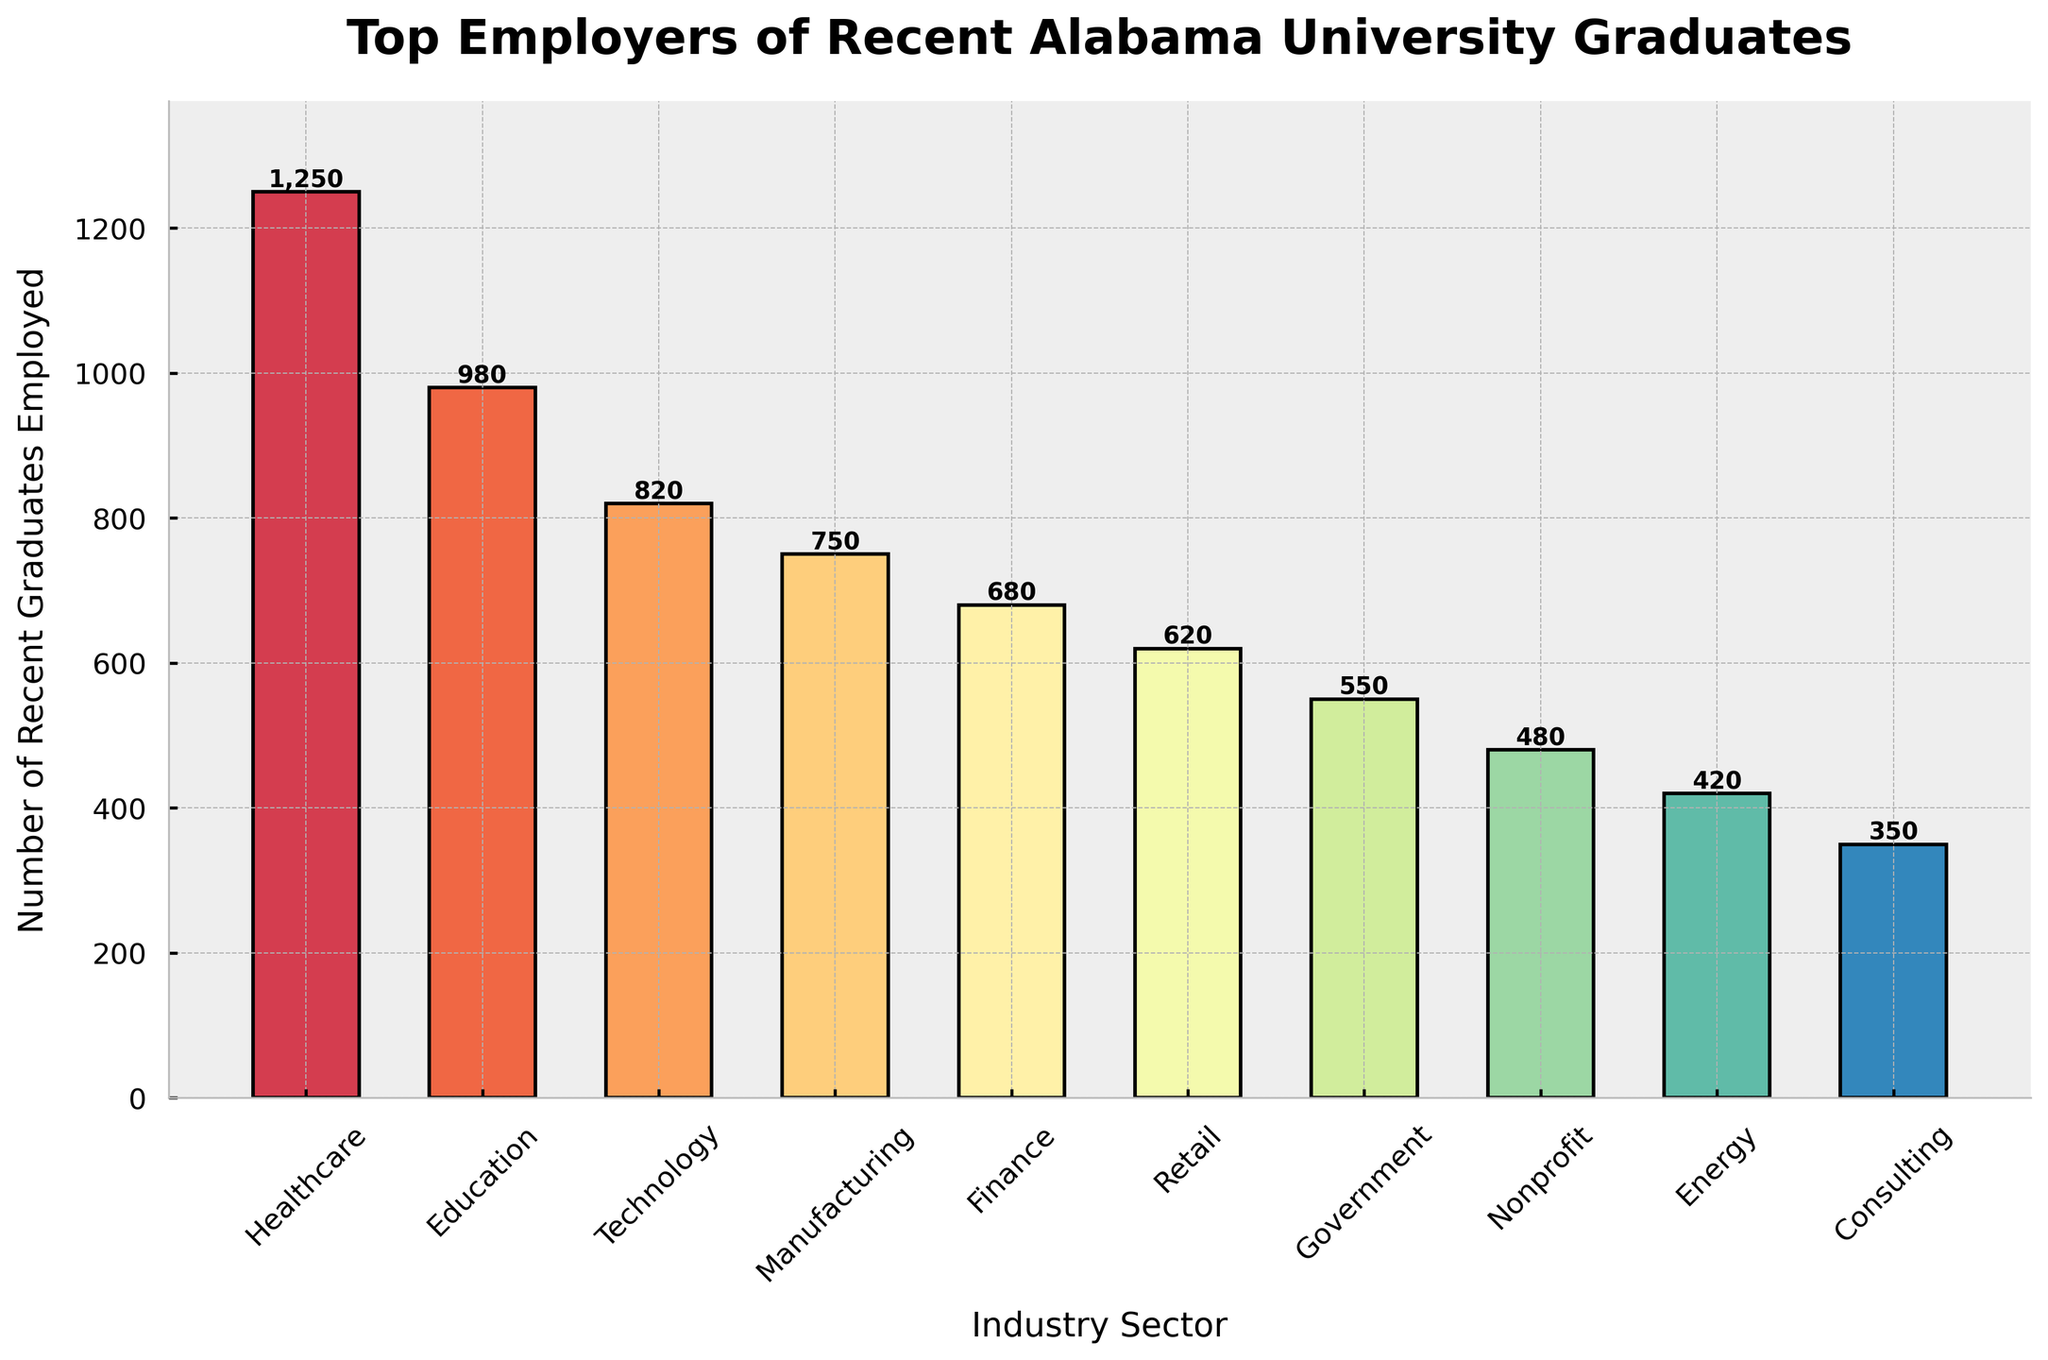Which industry sector employs the most recent graduates? The bar chart indicates that the 'Healthcare' sector has the highest bar, which represents 1,250 recent graduates employed
Answer: Healthcare How many more graduates are employed in Healthcare compared to Technology? The figure shows 1,250 graduates in Healthcare and 820 in Technology. The difference is 1,250 - 820 = 430
Answer: 430 Which industry sector employs the fewest recent graduates? The 'Consulting' sector has the shortest bar in the chart, representing 350 recent graduates employed
Answer: Consulting What is the total number of recent graduates employed in the top three industry sectors? The top three sectors are Healthcare (1,250), Education (980), and Technology (820). Summing these up: 1,250 + 980 + 820 = 3,050
Answer: 3,050 Which industry sectors employ more than 600 recent graduates? From the chart, the sectors that employ more than 600 graduates are Healthcare (1,250), Education (980), Technology (820), Manufacturing (750), and Finance (680)
Answer: Healthcare, Education, Technology, Manufacturing, Finance How does the number of graduates employed in the Government sector compare to the Finance sector? Government employs 550 graduates, and Finance employs 680 graduates. The Government sector employs fewer graduates by 680 - 550 = 130
Answer: 130 fewer What is the combined number of graduates employed in the Nonprofit and Energy sectors? Nonprofit employs 480 graduates, and Energy employs 420 graduates. Their combined number is 480 + 420 = 900
Answer: 900 Which sectors have a difference in graduate employment of more than 200 compared to Manufacturing? Manufacturing employs 750 graduates. Healthcare (1,250), Education (980), and Technology (820) each have a difference of more than 200 graduates compared to Manufacturing
Answer: Healthcare, Education, Technology When comparing the Retail and Consulting sectors, which one employs more graduates, and by how much? Retail employs 620 graduates, while Consulting employs 350 graduates. Retail employs more graduates by 620 - 350 = 270
Answer: Retail by 270 Is the number of recent graduates employed in Energy greater or smaller than the number employed in Nonprofit? The bar for Energy is shorter than that for Nonprofit. Energy employs 420 graduates, while Nonprofit employs 480 graduates, so Energy is smaller by 480 - 420 = 60
Answer: Smaller by 60 